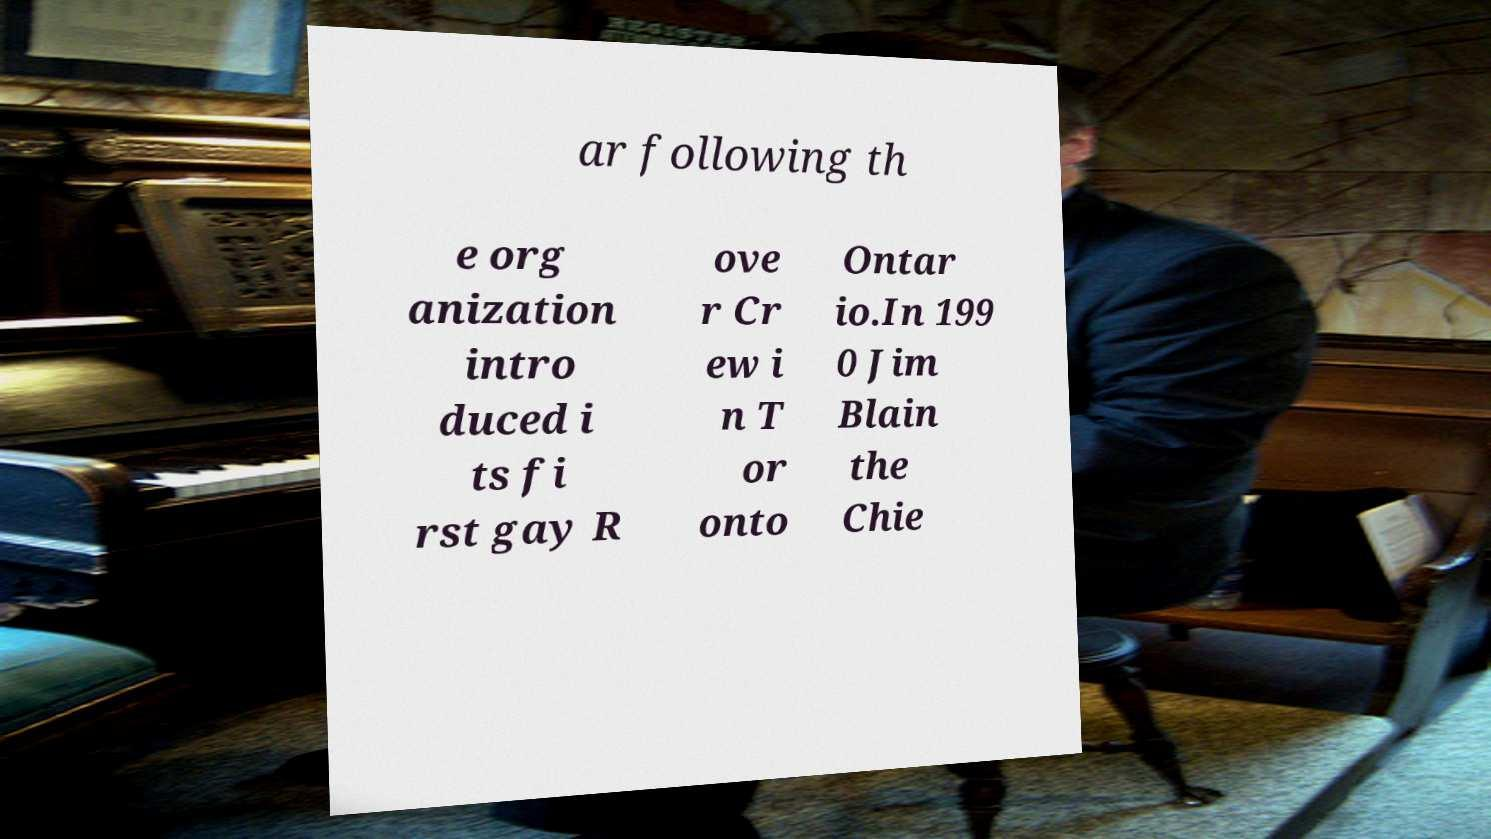Can you read and provide the text displayed in the image?This photo seems to have some interesting text. Can you extract and type it out for me? ar following th e org anization intro duced i ts fi rst gay R ove r Cr ew i n T or onto Ontar io.In 199 0 Jim Blain the Chie 